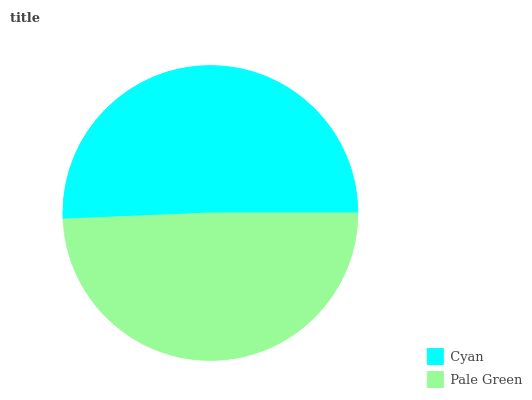Is Pale Green the minimum?
Answer yes or no. Yes. Is Cyan the maximum?
Answer yes or no. Yes. Is Pale Green the maximum?
Answer yes or no. No. Is Cyan greater than Pale Green?
Answer yes or no. Yes. Is Pale Green less than Cyan?
Answer yes or no. Yes. Is Pale Green greater than Cyan?
Answer yes or no. No. Is Cyan less than Pale Green?
Answer yes or no. No. Is Cyan the high median?
Answer yes or no. Yes. Is Pale Green the low median?
Answer yes or no. Yes. Is Pale Green the high median?
Answer yes or no. No. Is Cyan the low median?
Answer yes or no. No. 